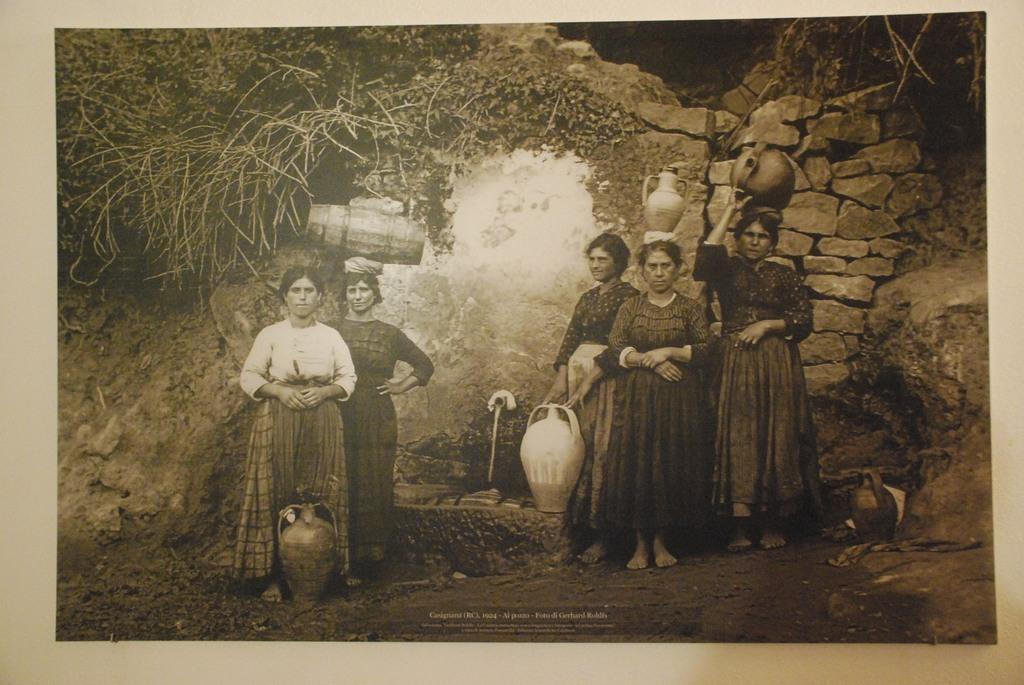Please provide a concise description of this image. It is an old image there are group of women standing in front of a cave by holding some objects on their head and hands. 